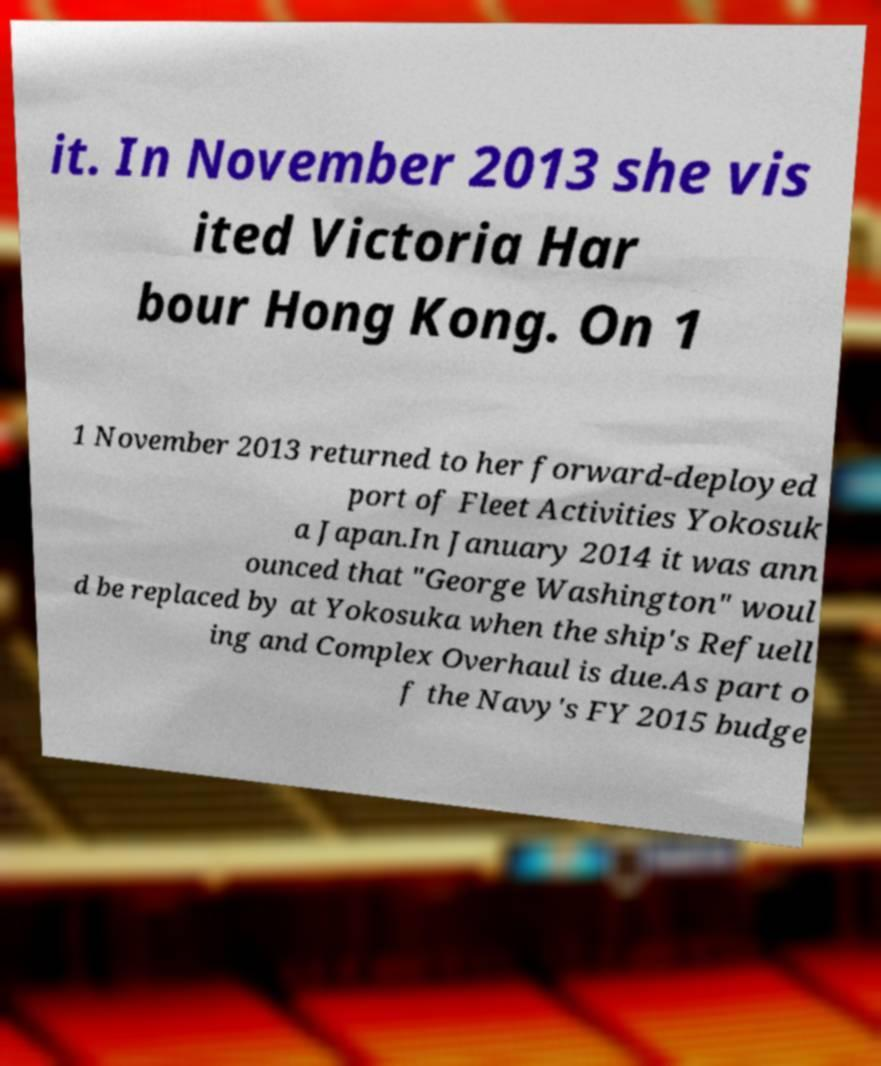Please identify and transcribe the text found in this image. it. In November 2013 she vis ited Victoria Har bour Hong Kong. On 1 1 November 2013 returned to her forward-deployed port of Fleet Activities Yokosuk a Japan.In January 2014 it was ann ounced that "George Washington" woul d be replaced by at Yokosuka when the ship's Refuell ing and Complex Overhaul is due.As part o f the Navy's FY 2015 budge 